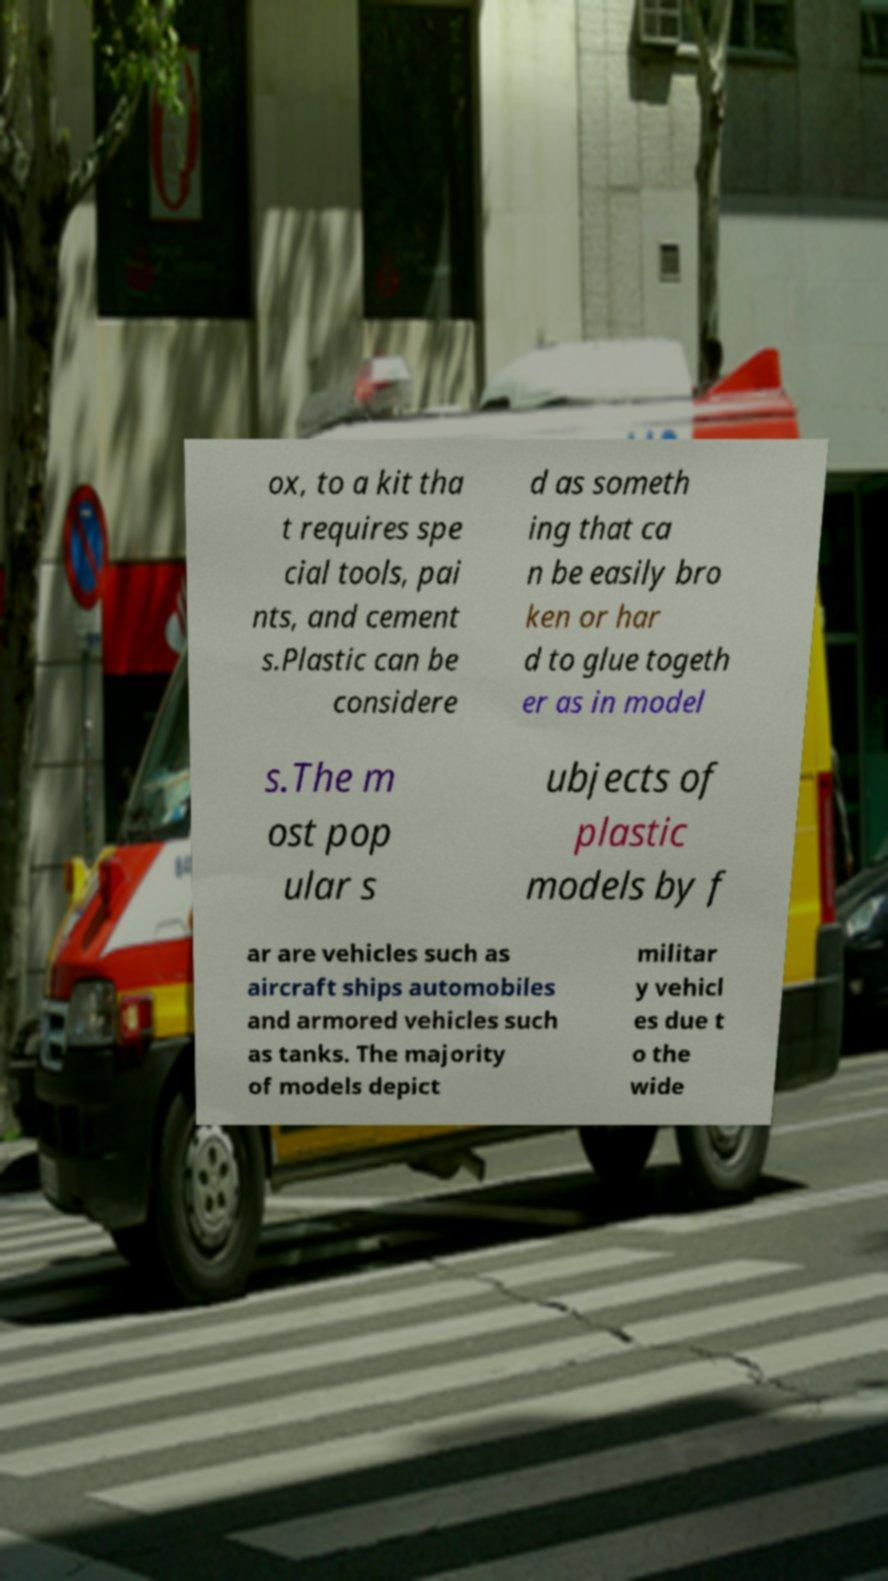Could you assist in decoding the text presented in this image and type it out clearly? ox, to a kit tha t requires spe cial tools, pai nts, and cement s.Plastic can be considere d as someth ing that ca n be easily bro ken or har d to glue togeth er as in model s.The m ost pop ular s ubjects of plastic models by f ar are vehicles such as aircraft ships automobiles and armored vehicles such as tanks. The majority of models depict militar y vehicl es due t o the wide 